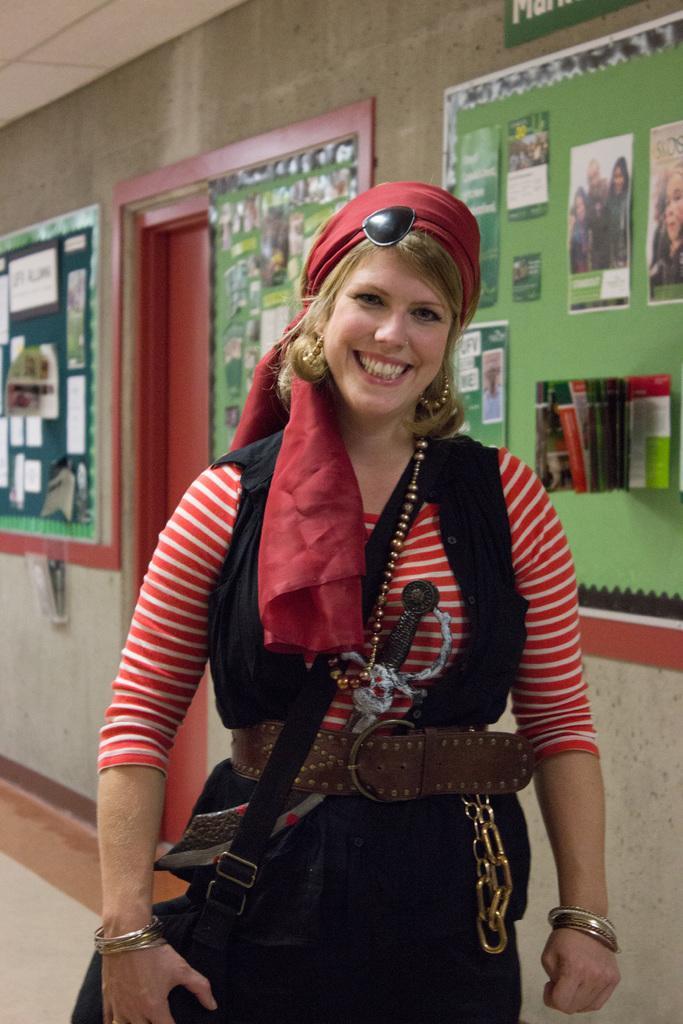Please provide a concise description of this image. In this picture I can see a wall with few green boards and I can see posters on the boards and I can see a woman standing, she wore a bag and I can see smile on her face. 